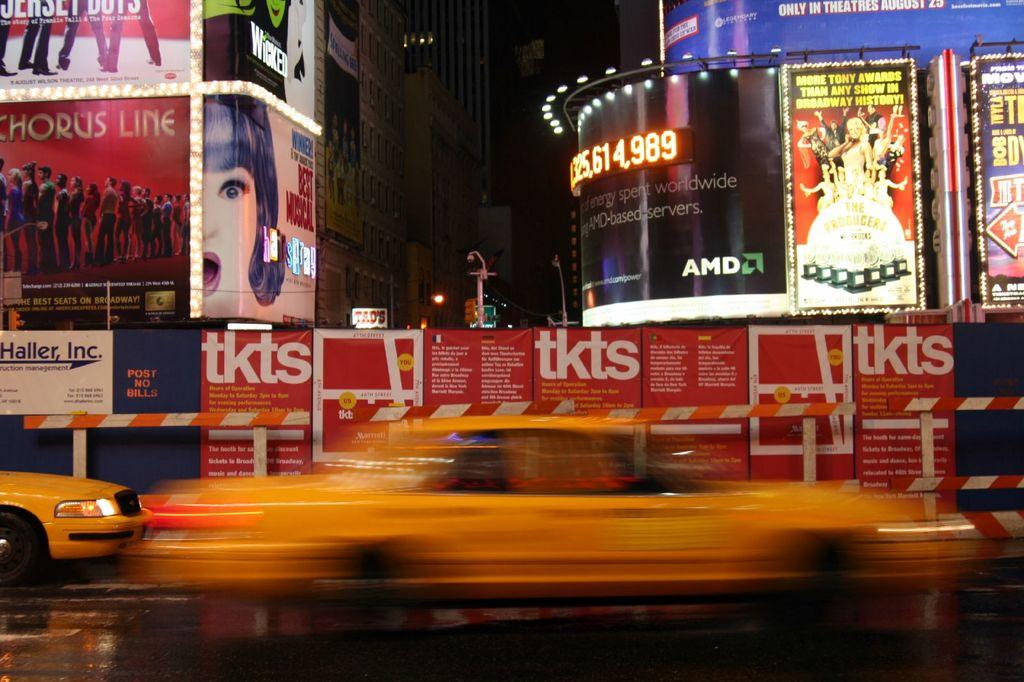Provide a one-sentence caption for the provided image. One of the Broadway shows being shown is a Chorus Line. 